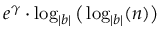Convert formula to latex. <formula><loc_0><loc_0><loc_500><loc_500>e ^ { \gamma } \cdot \log _ { | b | } { \left ( } \log _ { | b | } ( n ) { \right ) }</formula> 